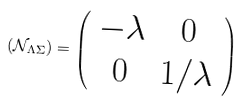Convert formula to latex. <formula><loc_0><loc_0><loc_500><loc_500>( \mathcal { N } _ { \Lambda \Sigma } ) = \left ( \begin{array} { c c } - \lambda & 0 \\ 0 & 1 / \lambda \\ \end{array} \right )</formula> 